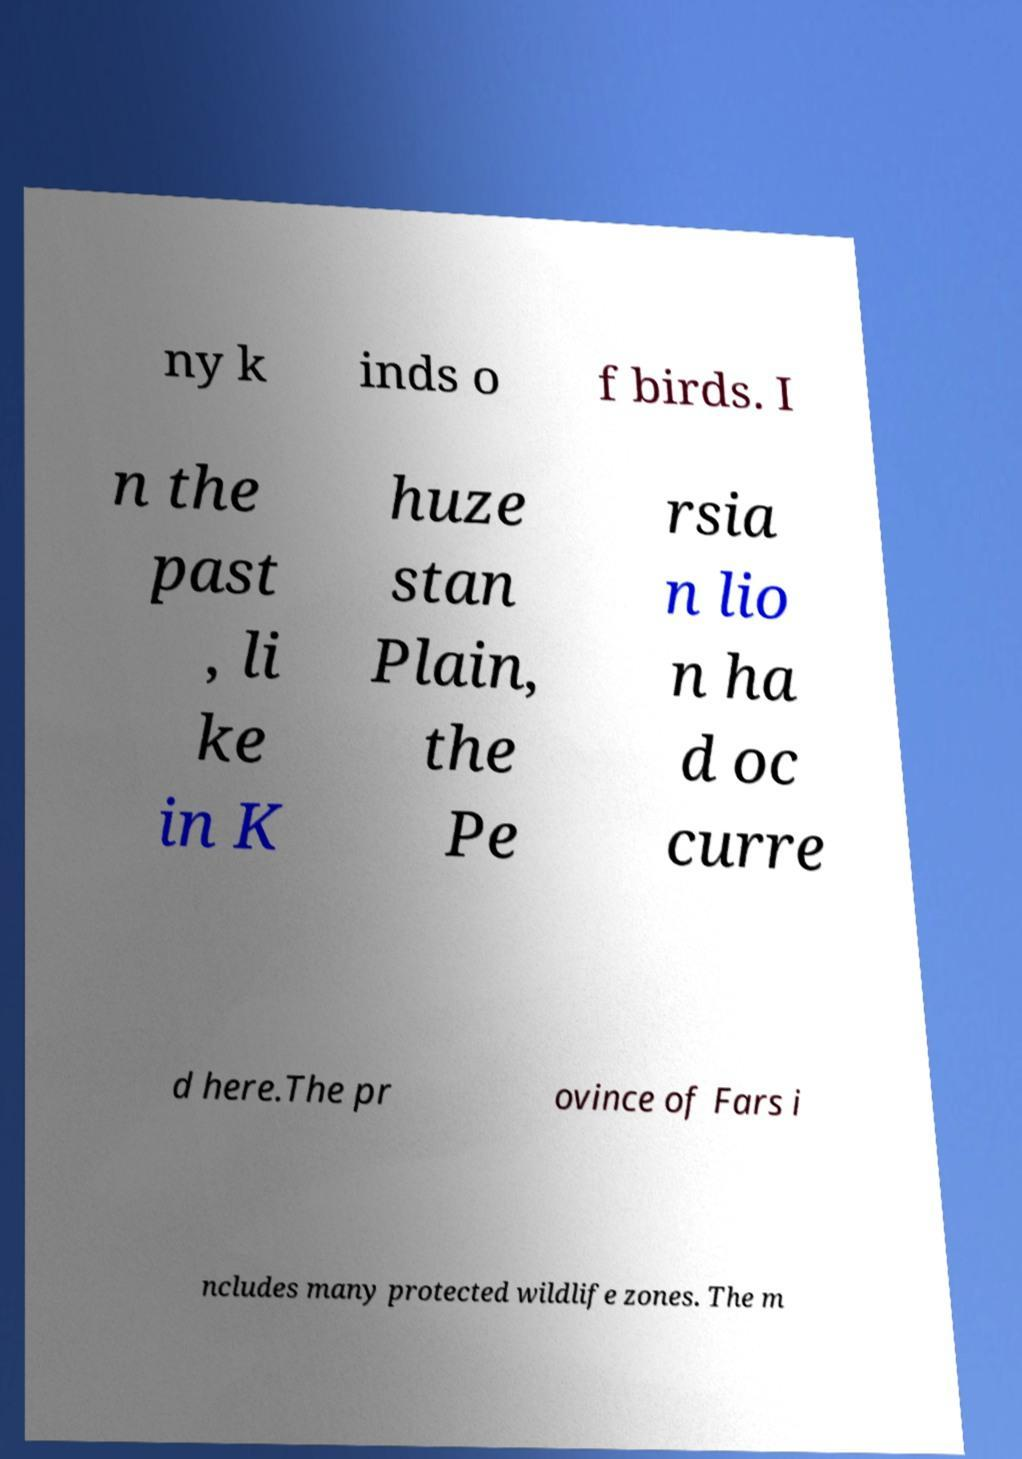Could you extract and type out the text from this image? ny k inds o f birds. I n the past , li ke in K huze stan Plain, the Pe rsia n lio n ha d oc curre d here.The pr ovince of Fars i ncludes many protected wildlife zones. The m 